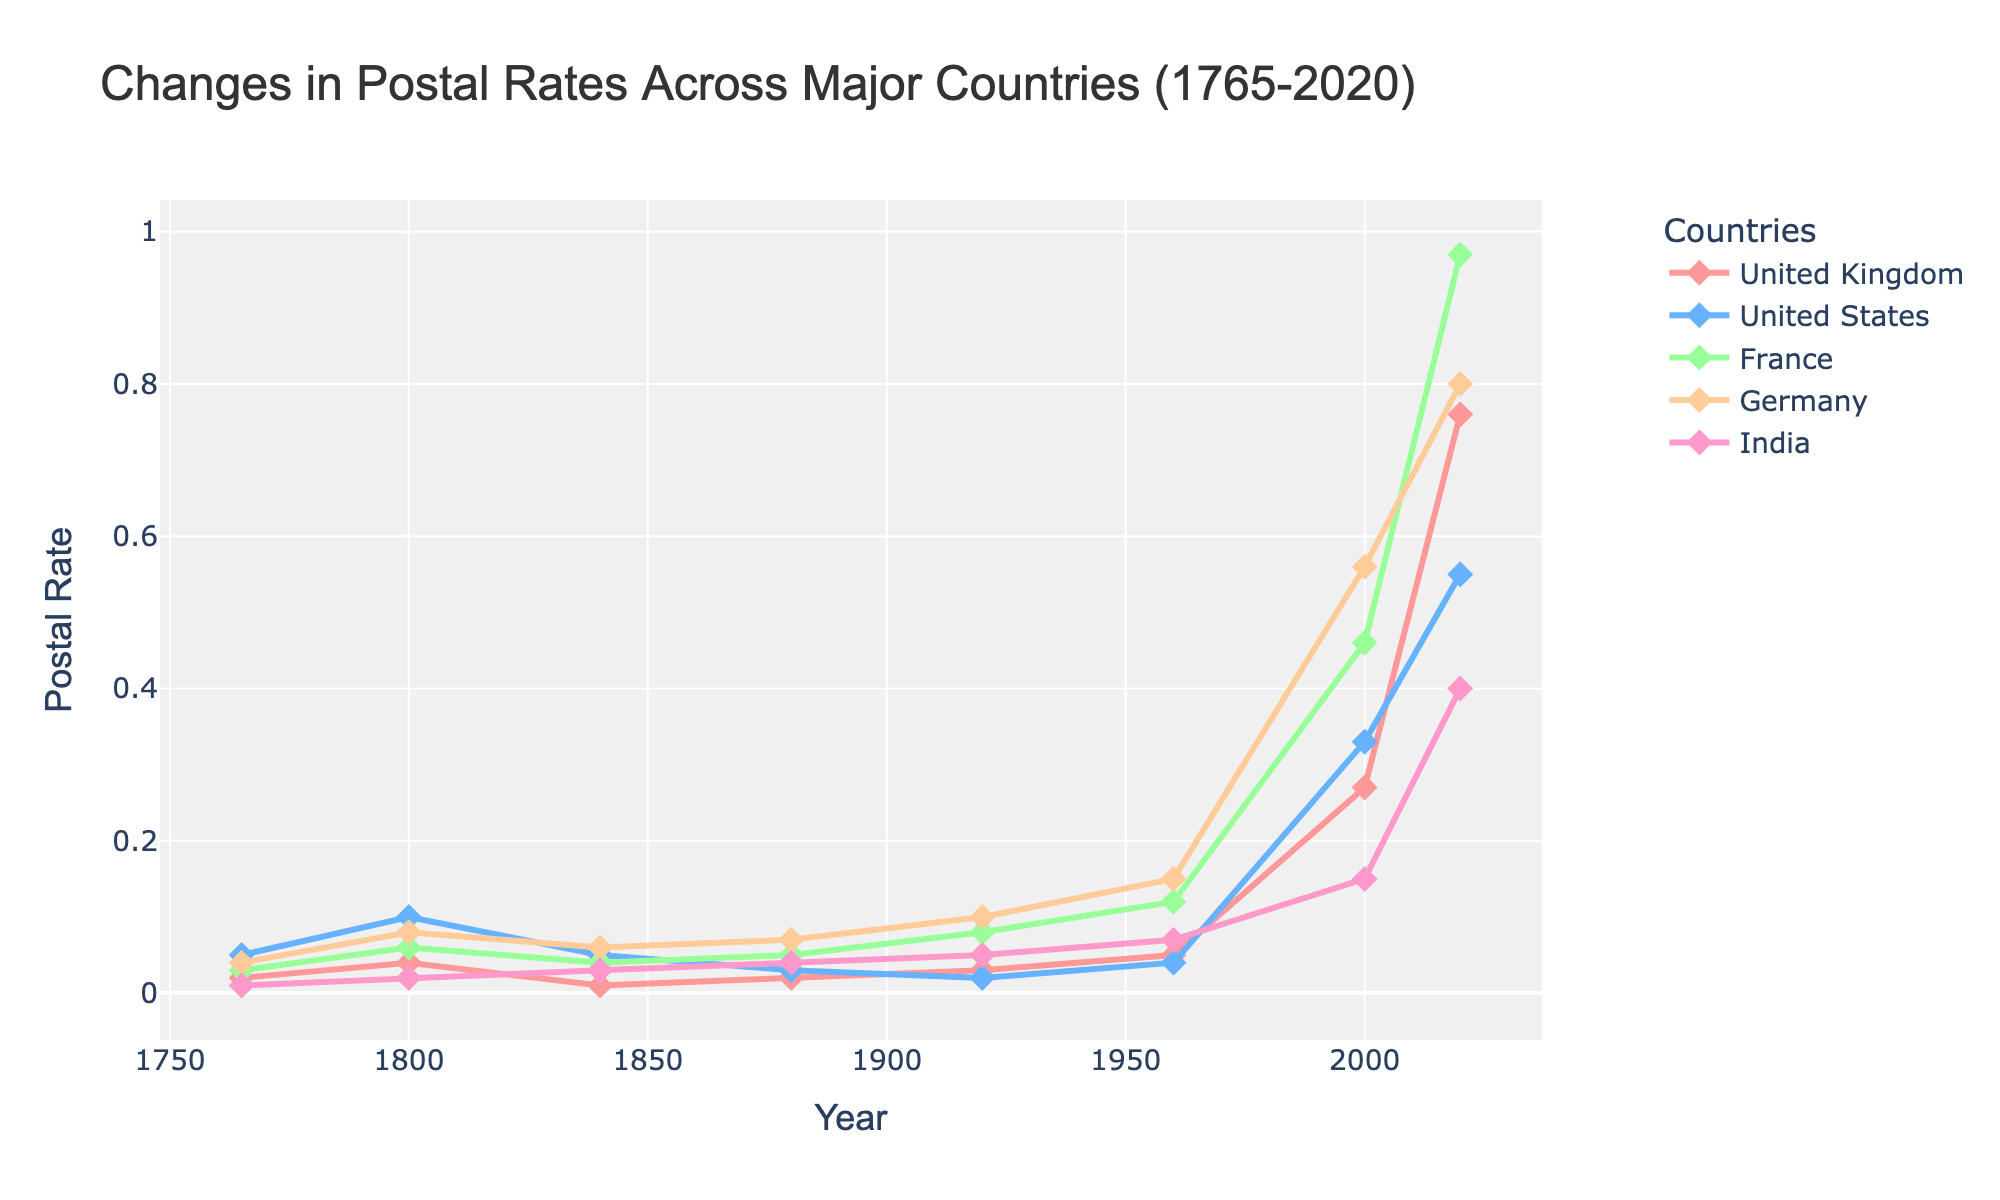What's the median postal rate for all countries in 2020? First, list all the postal rates for each country in 2020 which are 0.76 (United Kingdom), 0.55 (United States), 0.97 (France), 0.80 (Germany), and 0.40 (India). Arrange them in order: 0.40, 0.55, 0.76, 0.80, 0.97. The median value is the middle value of this ordered list.
Answer: 0.76 Which country had the highest postal rate in 1960? Look at the postal rates for all countries in 1960. The values are United Kingdom (0.05), United States (0.04), France (0.12), Germany (0.15), and India (0.07). The highest value is 0.15 for Germany.
Answer: Germany By how much did the postal rate in the United States increase from 1920 to 2020? First, find the postal rates for the United States in 1920 and 2020 which are 0.02 and 0.55 respectively. Subtract the rate in 1920 from the rate in 2020; 0.55 - 0.02 = 0.53.
Answer: 0.53 Which country had the smallest increase in postal rates from 1765 to 2020? Look at the rates for all the countries in 1765 and 2020. Calculate the increase for each: UK (0.76 - 0.02 = 0.74), US (0.55 - 0.05 = 0.50), France (0.97 - 0.03 = 0.94), Germany (0.80 - 0.04 = 0.76), and India (0.40 - 0.01 = 0.39). The smallest increase is for India with 0.39.
Answer: India Between which consecutive years did the postal rate in France increase the most? Look at the postal rates for France over the years: 0.03 (1765), 0.06 (1800), 0.04 (1840), 0.05 (1880), 0.08 (1920), 0.12 (1960), 0.46 (2000), and 0.97 (2020). Calculate the differences: (0.06 - 0.03 = 0.03), (0.04 - 0.06 = -0.02), (0.05 - 0.04 = 0.01), (0.08 - 0.05 = 0.03), (0.12 - 0.08 = 0.04), (0.46 - 0.12 = 0.34), (0.97 - 0.46 = 0.51). The largest increase is between 2000 and 2020 (0.51).
Answer: 2000 and 2020 Which country's postal rate was the highest in 2000 and what was the value? Look at the postal rates for all countries in 2000. The values are United Kingdom (0.27), United States (0.33), France (0.46), Germany (0.56), and India (0.15). The highest rate is 0.56 for Germany.
Answer: Germany, 0.56 What is the average postal rate in 1880 for all five countries? First, list the postal rates for all countries in 1880: United Kingdom (0.02), United States (0.03), France (0.05), Germany (0.07), India (0.04). Sum them up: 0.02 + 0.03 + 0.05 + 0.07 + 0.04 = 0.21. Divide by 5 (number of countries): 0.21 / 5 = 0.042.
Answer: 0.042 